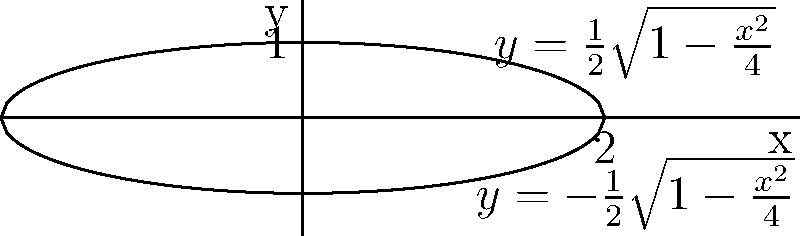A pill capsule can be modeled by rotating the region bounded by the curves $y=\frac{1}{2}\sqrt{1-\frac{x^2}{4}}$ and $y=-\frac{1}{2}\sqrt{1-\frac{x^2}{4}}$ about the y-axis. Calculate the volume of this pill capsule. To find the volume of the pill capsule, we need to use the shell method for rotational solids. Here's the step-by-step solution:

1) The shell method formula for volume is:
   $$V = 2\pi \int_a^b x f(x) dx$$
   where $f(x)$ is the distance from the axis of rotation to the curve.

2) In this case, $f(x) = \frac{1}{2}\sqrt{1-\frac{x^2}{4}}$, $a = 0$, and $b = 2$.

3) Substituting into the formula:
   $$V = 2\pi \int_0^2 x \cdot \frac{1}{2}\sqrt{1-\frac{x^2}{4}} dx$$

4) Simplify:
   $$V = \pi \int_0^2 x \sqrt{1-\frac{x^2}{4}} dx$$

5) This integral is complex, but it can be solved using substitution. Let $u = 1-\frac{x^2}{4}$, then $du = -\frac{x}{2}dx$ or $dx = -\frac{2}{x}du$.

6) When $x = 0$, $u = 1$; when $x = 2$, $u = 0$. The limits of integration change accordingly.

7) Substituting:
   $$V = \pi \int_1^0 x \cdot \sqrt{u} \cdot (-\frac{2}{x})du = -2\pi \int_1^0 \sqrt{u} du$$

8) Solve the integral:
   $$V = -2\pi [\frac{2}{3}u^{3/2}]_1^0 = -2\pi [\frac{2}{3}(0) - \frac{2}{3}(1)] = \frac{4\pi}{3}$$

Therefore, the volume of the pill capsule is $\frac{4\pi}{3}$ cubic units.
Answer: $\frac{4\pi}{3}$ cubic units 